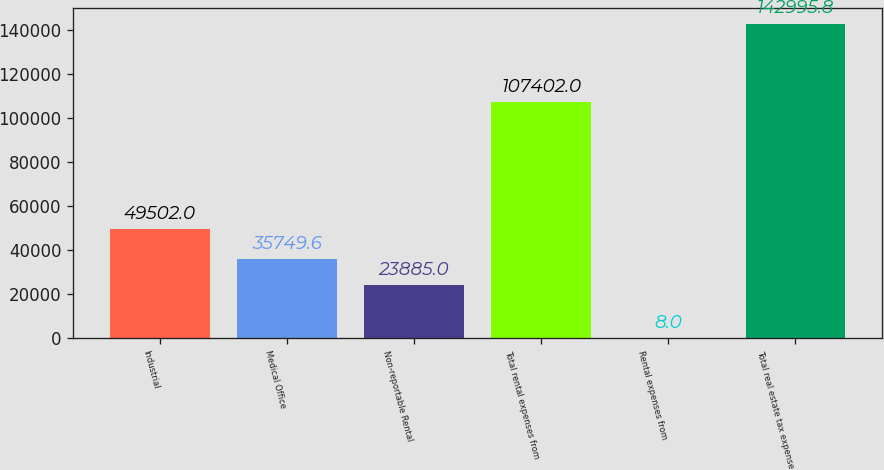Convert chart. <chart><loc_0><loc_0><loc_500><loc_500><bar_chart><fcel>Industrial<fcel>Medical Office<fcel>Non-reportable Rental<fcel>Total rental expenses from<fcel>Rental expenses from<fcel>Total real estate tax expense<nl><fcel>49502<fcel>35749.6<fcel>23885<fcel>107402<fcel>8<fcel>142996<nl></chart> 